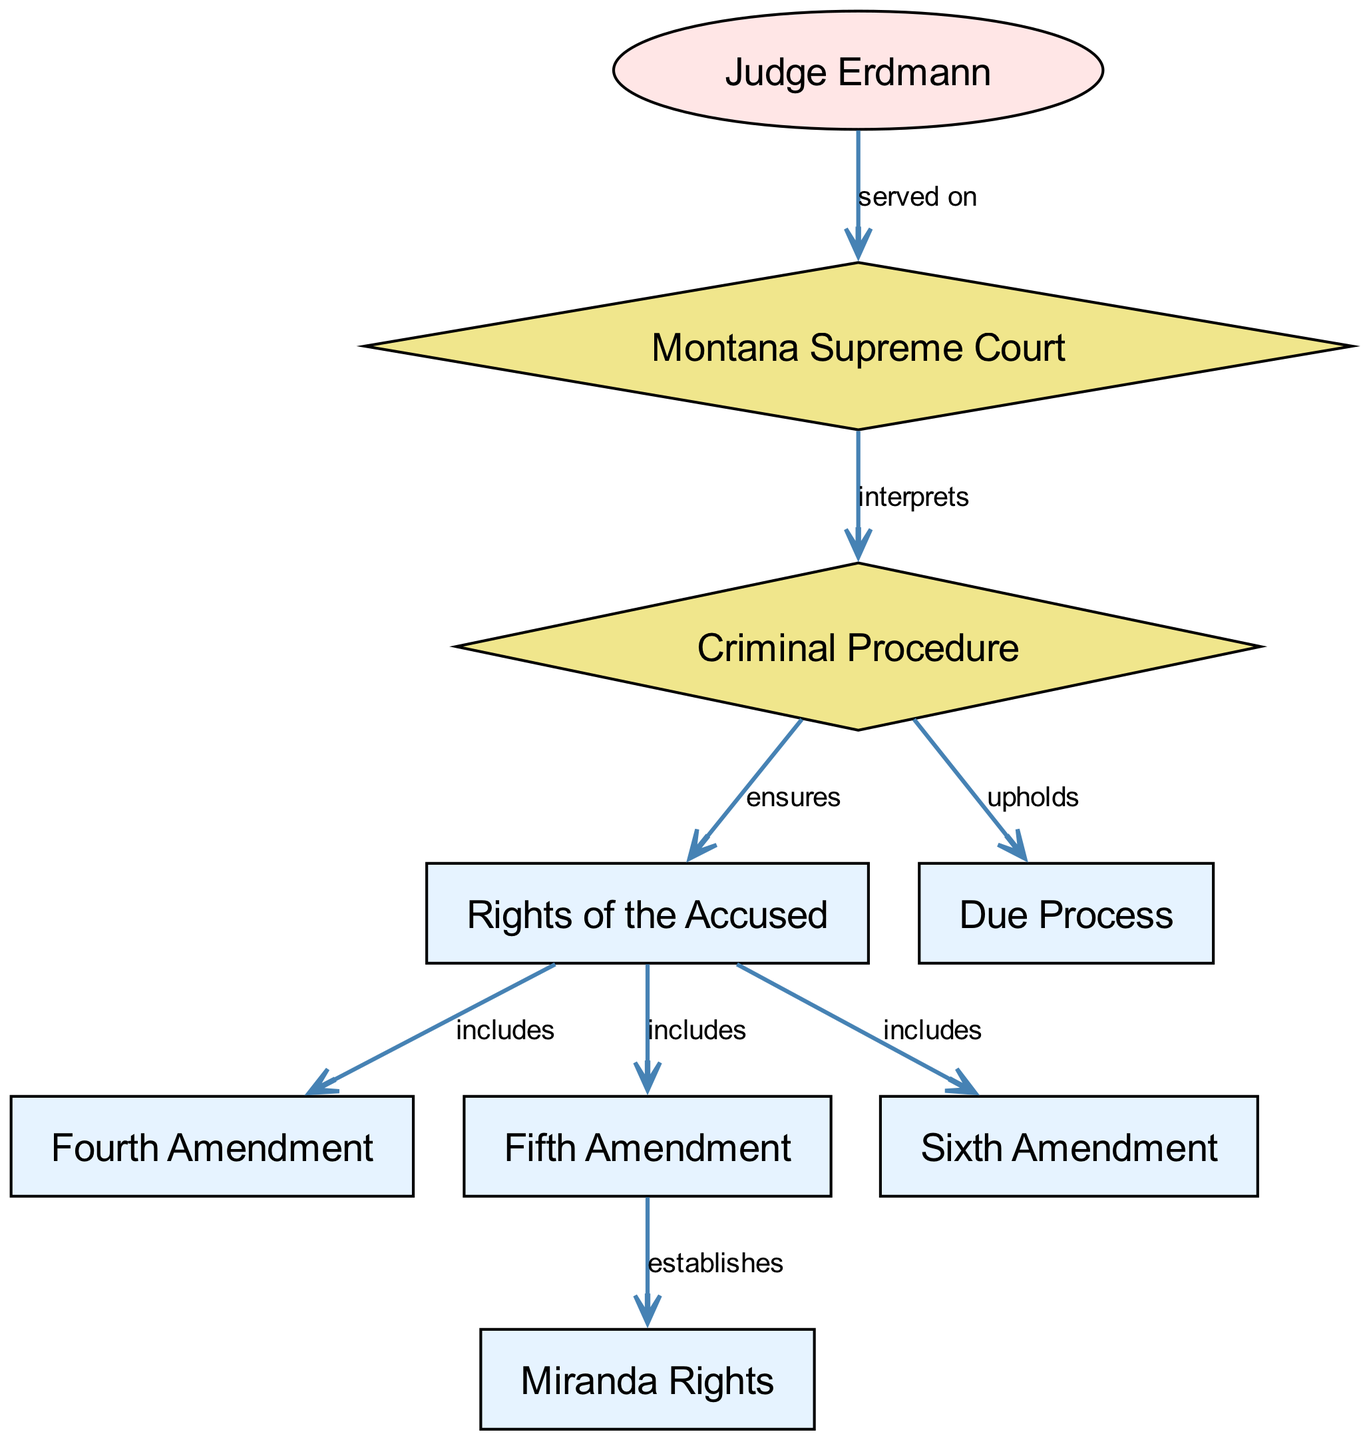What are the rights of the accused? The diagram indicates that the "Rights of the Accused" include the Fourth Amendment, Fifth Amendment, and Sixth Amendment. Each of these amendments embodies specific rights provided to individuals accused of criminal offenses.
Answer: Fourth Amendment, Fifth Amendment, Sixth Amendment How many nodes are in the diagram? By counting the distinct elements represented in the diagram, we find a total of 8 nodes: criminal procedure, rights of the accused, fourth amendment, fifth amendment, sixth amendment, Judge Erdmann, Montana Supreme Court, miranda rights, and due process.
Answer: 8 What does the Fifth Amendment establish? The diagram shows a direct connection from the Fifth Amendment to Miranda Rights, indicating that the Fifth Amendment is the source of Miranda Rights, which protect an individual's right against self-incrimination.
Answer: Miranda Rights How does criminal procedure relate to due process? The diagram illustrates that criminal procedure upholds due process, signifying that procedural safeguards in the legal system are designed to ensure fair treatment through the judicial process.
Answer: Upholds Who served on the Montana Supreme Court? The diagram designates that Judge Erdmann served on the Montana Supreme Court, explicitly connecting his name to the court’s structure within the node relationships.
Answer: Judge Erdmann What does the Montana Supreme Court do? According to the diagram, the Montana Supreme Court interprets criminal procedure, which involves clarifying and applying the laws and amendments regarding the criminal justice system within the state jurisdiction.
Answer: Interprets Which amendment includes Miranda Rights? The diagram connects the Fifth Amendment directly to Miranda Rights, indicating that Miranda Rights are a component of the rights defined within the scope of the Fifth Amendment.
Answer: Fifth Amendment What is included in the rights of the accused? The diagram lists the components of the rights of the accused, which are specifically the Fourth Amendment, Fifth Amendment, and Sixth Amendment, illustrating the protections afforded under these amendments.
Answer: Fourth Amendment, Fifth Amendment, Sixth Amendment 